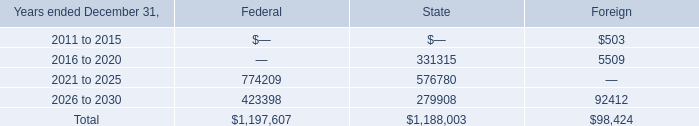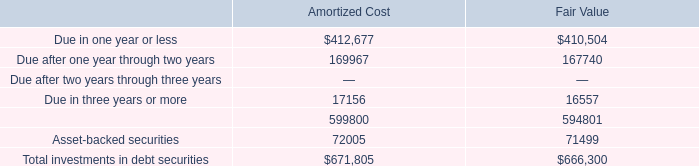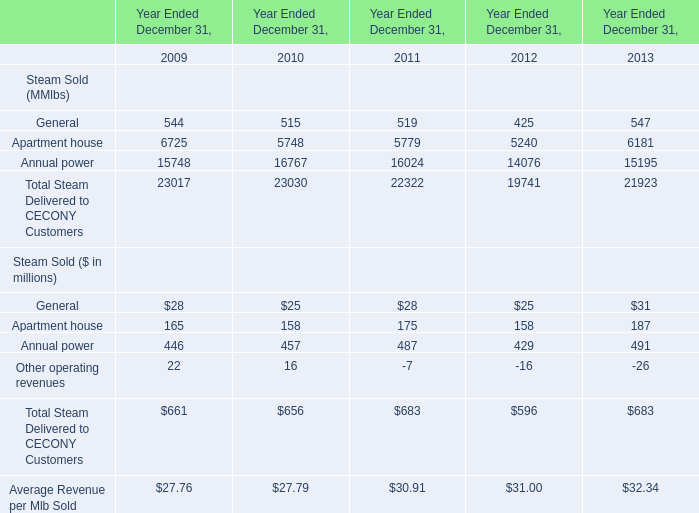What is the sum of the Average Revenue per Mlb Sold in the years where Other operating revenues is positive? (in million) 
Computations: (27.76 + 27.79)
Answer: 55.55. 